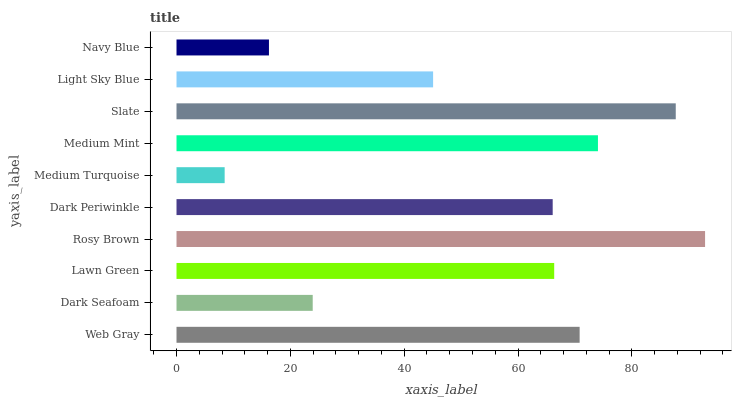Is Medium Turquoise the minimum?
Answer yes or no. Yes. Is Rosy Brown the maximum?
Answer yes or no. Yes. Is Dark Seafoam the minimum?
Answer yes or no. No. Is Dark Seafoam the maximum?
Answer yes or no. No. Is Web Gray greater than Dark Seafoam?
Answer yes or no. Yes. Is Dark Seafoam less than Web Gray?
Answer yes or no. Yes. Is Dark Seafoam greater than Web Gray?
Answer yes or no. No. Is Web Gray less than Dark Seafoam?
Answer yes or no. No. Is Lawn Green the high median?
Answer yes or no. Yes. Is Dark Periwinkle the low median?
Answer yes or no. Yes. Is Navy Blue the high median?
Answer yes or no. No. Is Light Sky Blue the low median?
Answer yes or no. No. 